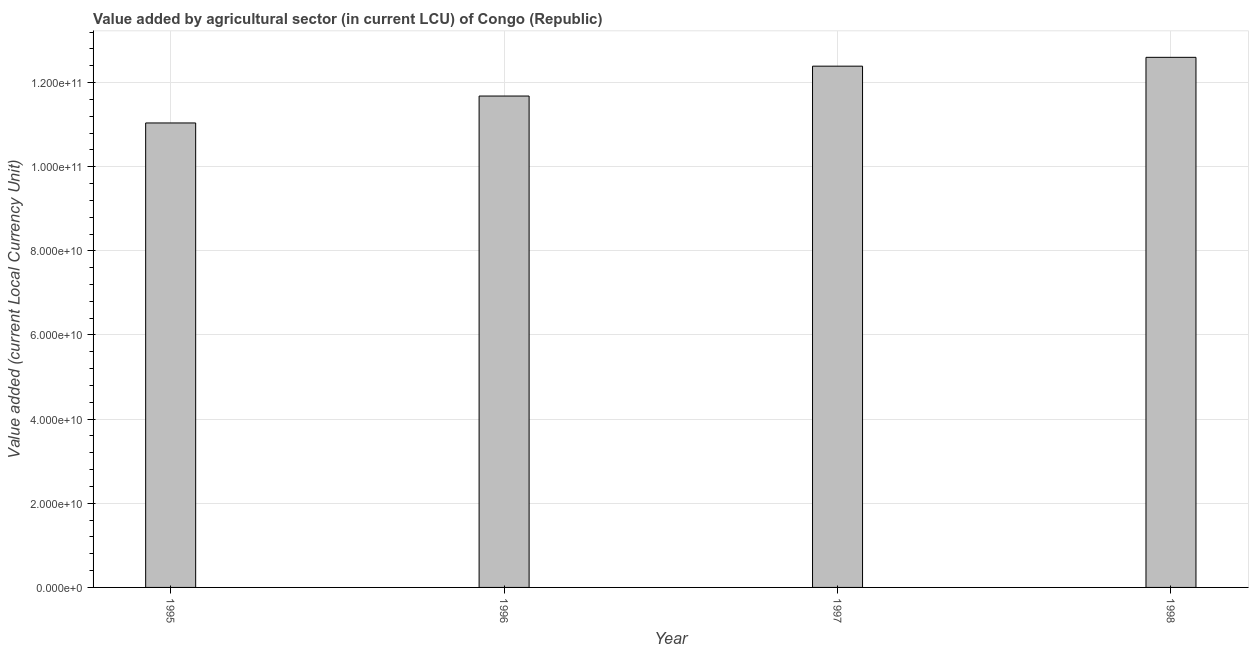Does the graph contain any zero values?
Make the answer very short. No. Does the graph contain grids?
Your answer should be very brief. Yes. What is the title of the graph?
Provide a succinct answer. Value added by agricultural sector (in current LCU) of Congo (Republic). What is the label or title of the X-axis?
Keep it short and to the point. Year. What is the label or title of the Y-axis?
Your answer should be compact. Value added (current Local Currency Unit). What is the value added by agriculture sector in 1995?
Provide a short and direct response. 1.10e+11. Across all years, what is the maximum value added by agriculture sector?
Your response must be concise. 1.26e+11. Across all years, what is the minimum value added by agriculture sector?
Your response must be concise. 1.10e+11. In which year was the value added by agriculture sector maximum?
Your answer should be very brief. 1998. What is the sum of the value added by agriculture sector?
Your response must be concise. 4.77e+11. What is the difference between the value added by agriculture sector in 1995 and 1996?
Make the answer very short. -6.40e+09. What is the average value added by agriculture sector per year?
Your answer should be compact. 1.19e+11. What is the median value added by agriculture sector?
Offer a terse response. 1.20e+11. What is the ratio of the value added by agriculture sector in 1995 to that in 1998?
Provide a short and direct response. 0.88. Is the value added by agriculture sector in 1995 less than that in 1997?
Your answer should be compact. Yes. Is the difference between the value added by agriculture sector in 1995 and 1996 greater than the difference between any two years?
Provide a short and direct response. No. What is the difference between the highest and the second highest value added by agriculture sector?
Provide a short and direct response. 2.10e+09. Is the sum of the value added by agriculture sector in 1995 and 1998 greater than the maximum value added by agriculture sector across all years?
Offer a terse response. Yes. What is the difference between the highest and the lowest value added by agriculture sector?
Your response must be concise. 1.56e+1. In how many years, is the value added by agriculture sector greater than the average value added by agriculture sector taken over all years?
Your response must be concise. 2. How many years are there in the graph?
Keep it short and to the point. 4. What is the difference between two consecutive major ticks on the Y-axis?
Offer a terse response. 2.00e+1. What is the Value added (current Local Currency Unit) of 1995?
Ensure brevity in your answer.  1.10e+11. What is the Value added (current Local Currency Unit) of 1996?
Make the answer very short. 1.17e+11. What is the Value added (current Local Currency Unit) in 1997?
Provide a short and direct response. 1.24e+11. What is the Value added (current Local Currency Unit) of 1998?
Your response must be concise. 1.26e+11. What is the difference between the Value added (current Local Currency Unit) in 1995 and 1996?
Provide a short and direct response. -6.40e+09. What is the difference between the Value added (current Local Currency Unit) in 1995 and 1997?
Give a very brief answer. -1.35e+1. What is the difference between the Value added (current Local Currency Unit) in 1995 and 1998?
Keep it short and to the point. -1.56e+1. What is the difference between the Value added (current Local Currency Unit) in 1996 and 1997?
Make the answer very short. -7.10e+09. What is the difference between the Value added (current Local Currency Unit) in 1996 and 1998?
Keep it short and to the point. -9.20e+09. What is the difference between the Value added (current Local Currency Unit) in 1997 and 1998?
Ensure brevity in your answer.  -2.10e+09. What is the ratio of the Value added (current Local Currency Unit) in 1995 to that in 1996?
Ensure brevity in your answer.  0.94. What is the ratio of the Value added (current Local Currency Unit) in 1995 to that in 1997?
Provide a short and direct response. 0.89. What is the ratio of the Value added (current Local Currency Unit) in 1995 to that in 1998?
Give a very brief answer. 0.88. What is the ratio of the Value added (current Local Currency Unit) in 1996 to that in 1997?
Make the answer very short. 0.94. What is the ratio of the Value added (current Local Currency Unit) in 1996 to that in 1998?
Offer a terse response. 0.93. What is the ratio of the Value added (current Local Currency Unit) in 1997 to that in 1998?
Your response must be concise. 0.98. 